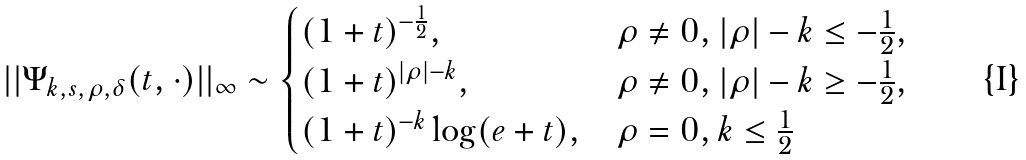<formula> <loc_0><loc_0><loc_500><loc_500>| | \Psi _ { k , s , \rho , \delta } ( t , \cdot ) | | _ { \infty } \sim \begin{cases} ( 1 + t ) ^ { - \frac { 1 } { 2 } } , & \rho \ne 0 , | \rho | - k \leq - \frac { 1 } { 2 } , \\ ( 1 + t ) ^ { | \rho | - k } , & \rho \ne 0 , | \rho | - k \geq - \frac { 1 } { 2 } , \\ ( 1 + t ) ^ { - k } \log ( e + t ) , & \rho = 0 , k \leq \frac { 1 } { 2 } \end{cases}</formula> 